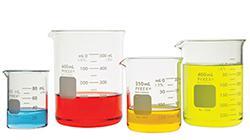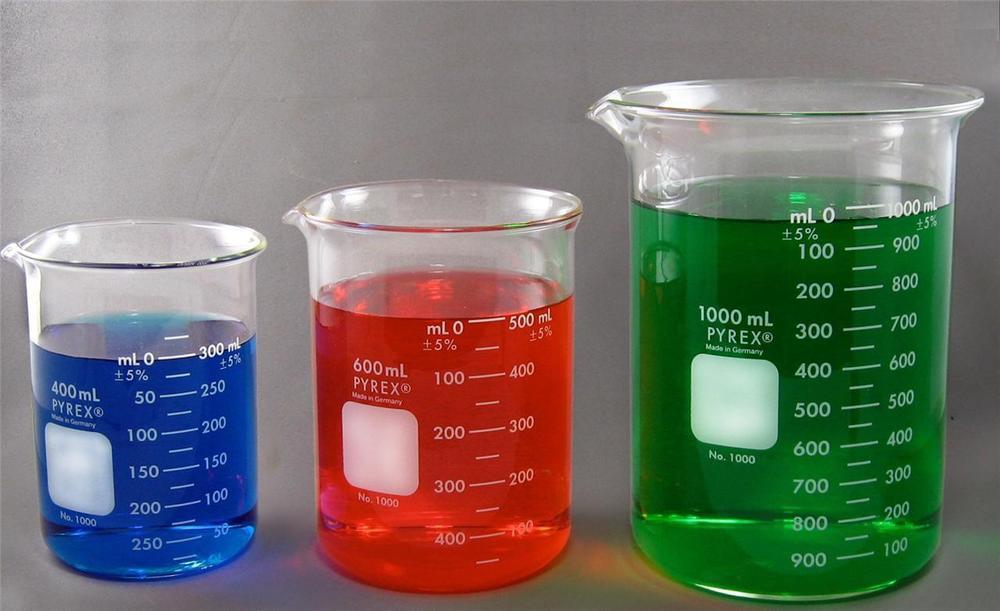The first image is the image on the left, the second image is the image on the right. Considering the images on both sides, is "Two beakers contain red liquid." valid? Answer yes or no. Yes. 